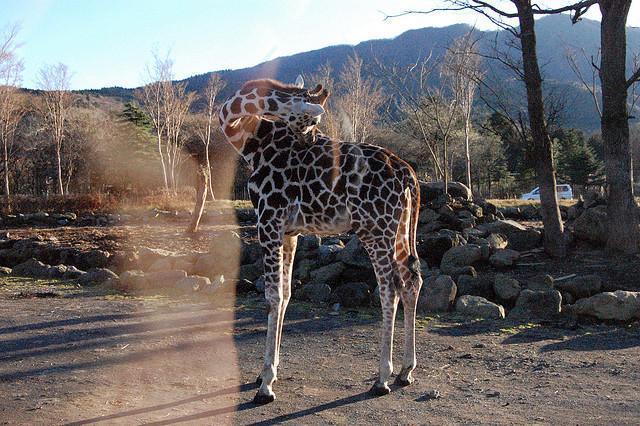How many donuts are there?
Give a very brief answer. 0. 